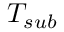<formula> <loc_0><loc_0><loc_500><loc_500>T _ { s u b }</formula> 